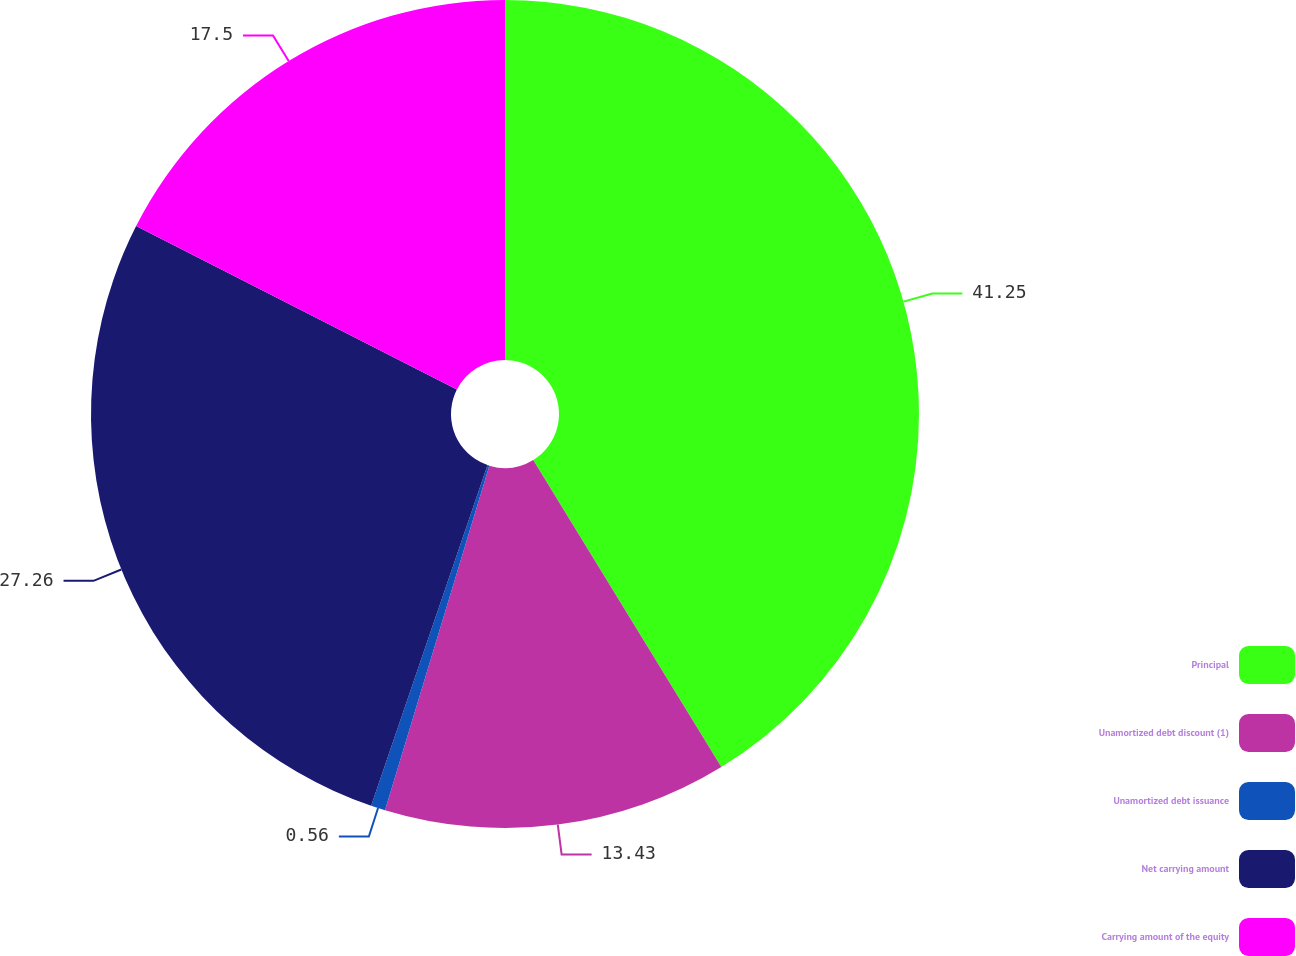Convert chart to OTSL. <chart><loc_0><loc_0><loc_500><loc_500><pie_chart><fcel>Principal<fcel>Unamortized debt discount (1)<fcel>Unamortized debt issuance<fcel>Net carrying amount<fcel>Carrying amount of the equity<nl><fcel>41.25%<fcel>13.43%<fcel>0.56%<fcel>27.26%<fcel>17.5%<nl></chart> 